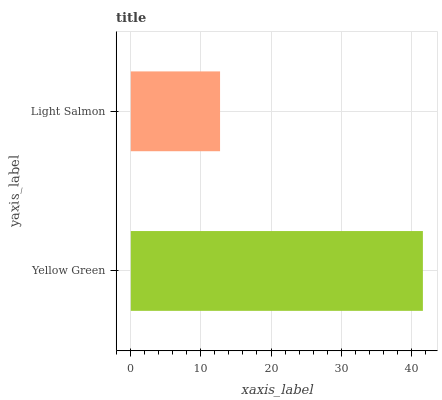Is Light Salmon the minimum?
Answer yes or no. Yes. Is Yellow Green the maximum?
Answer yes or no. Yes. Is Light Salmon the maximum?
Answer yes or no. No. Is Yellow Green greater than Light Salmon?
Answer yes or no. Yes. Is Light Salmon less than Yellow Green?
Answer yes or no. Yes. Is Light Salmon greater than Yellow Green?
Answer yes or no. No. Is Yellow Green less than Light Salmon?
Answer yes or no. No. Is Yellow Green the high median?
Answer yes or no. Yes. Is Light Salmon the low median?
Answer yes or no. Yes. Is Light Salmon the high median?
Answer yes or no. No. Is Yellow Green the low median?
Answer yes or no. No. 